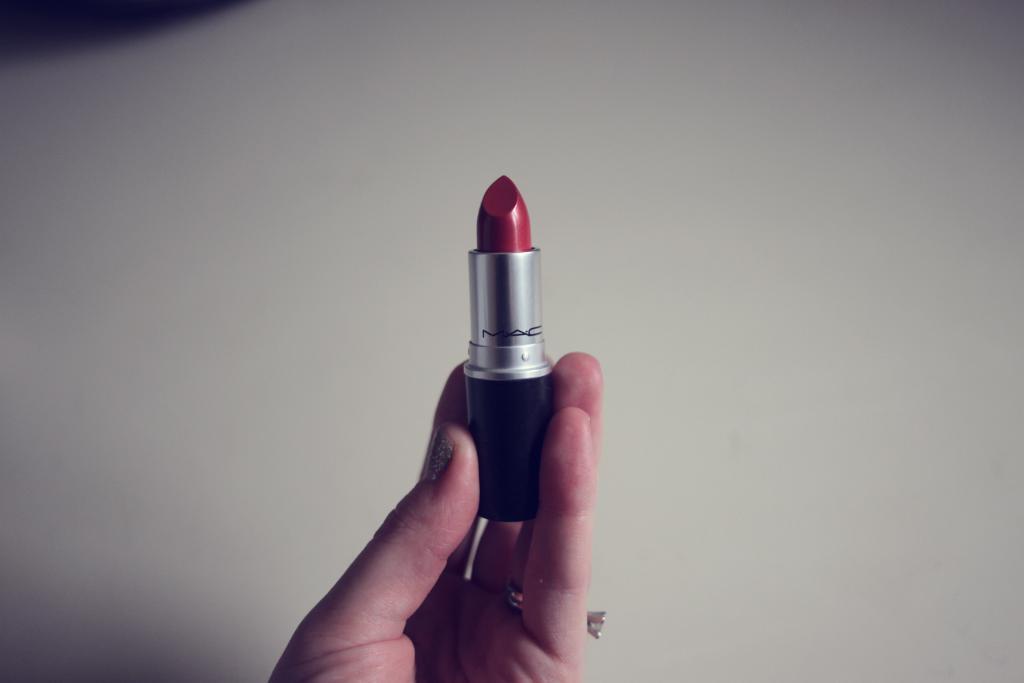Describe this image in one or two sentences. In this image I can see the person holding the lipstick and the lipstick is in red color and I can see the white color background. 